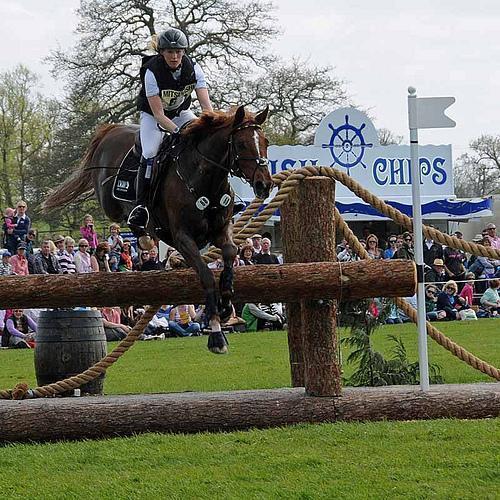How many barrels are there?
Give a very brief answer. 1. 